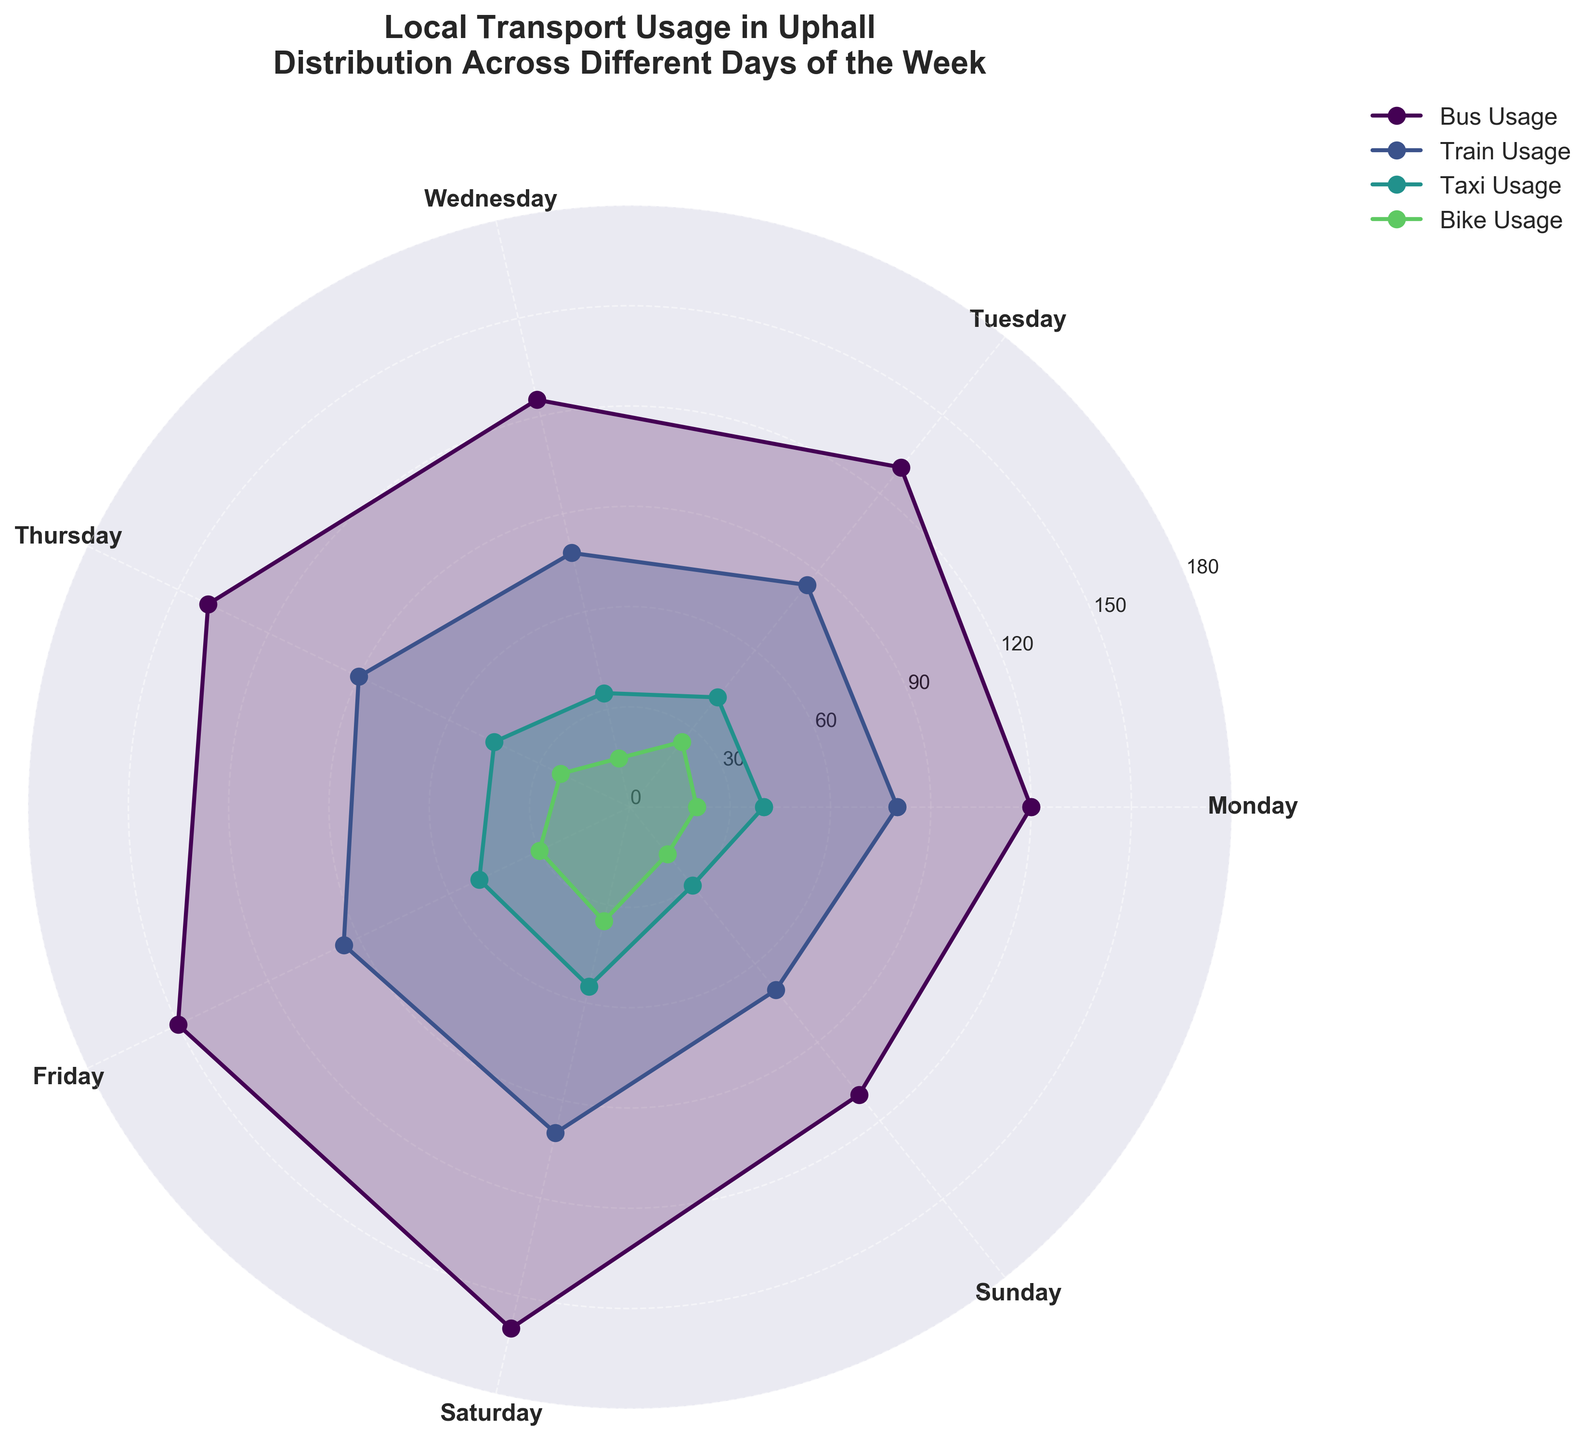what is the title of the plot? The title is written at the top of the chart.
Answer: Local Transport Usage in Uphall Distribution Across Different Days of the Week what are the four categories represented in the rose chart? It's indicated directly in the legend of the chart, where each category is labeled in a different color.
Answer: Bus Usage, Train Usage, Taxi Usage, Bike Usage on which day is bike usage the highest? Look at the Bike Usage data points around the chart for all days and find the highest value.
Answer: Saturday what is the difference in bus usage between Saturday and Sunday? Find the bus usage values for Saturday and Sunday around the chart and subtract Sunday’s value from Saturday’s value.
Answer: 50 which category has the most uniform (least variable) usage over the week? Compare the spread and variation of data points for each category around the chart.
Answer: Bike Usage between Friday and Saturday, which day has higher train usage? Look at Train Usage data points for both Friday and Saturday and compare them.
Answer: Saturday what is the average bus usage from Monday to Friday? Add the bus usage values from Monday to Friday and divide by 5.
Answer: 133 how does taxi usage on Wednesday compare to bike usage on the same day? Find taxi and bike usage values for Wednesday around the chart and compare them.
Answer: Taxi usage is higher which category shows the most significant increase from Monday to Friday? Look at all four categories' values on Monday and Friday and identify the category with the largest increase.
Answer: Bus Usage is there any day where train usage is less than bike usage? Compare the Train Usage and Bike Usage values for each day to see if there's any day where the bike usage exceeds train usage.
Answer: No 